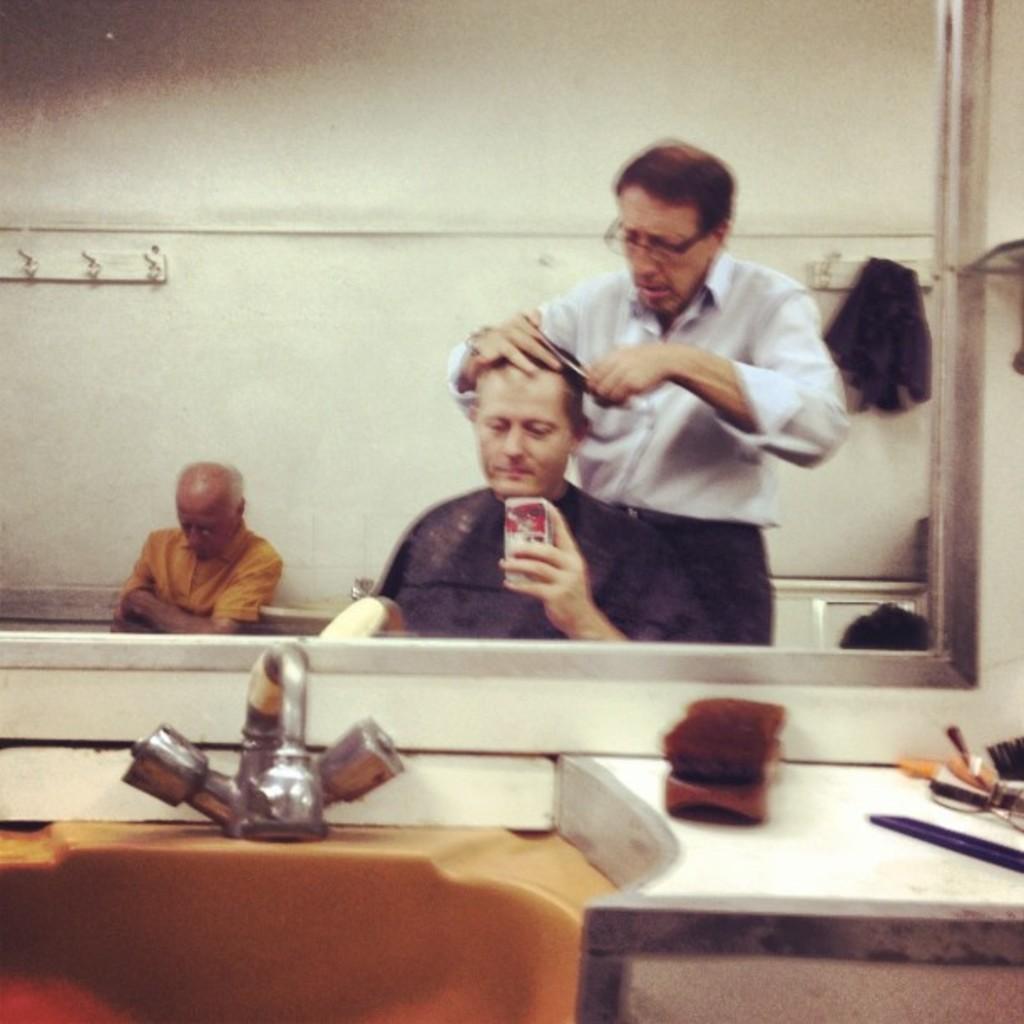Describe this image in one or two sentences. In this image as we can see there is a mirror and there is a reflection of a three persons in the middle ,and there are some objects kept at the bottom of this image. 